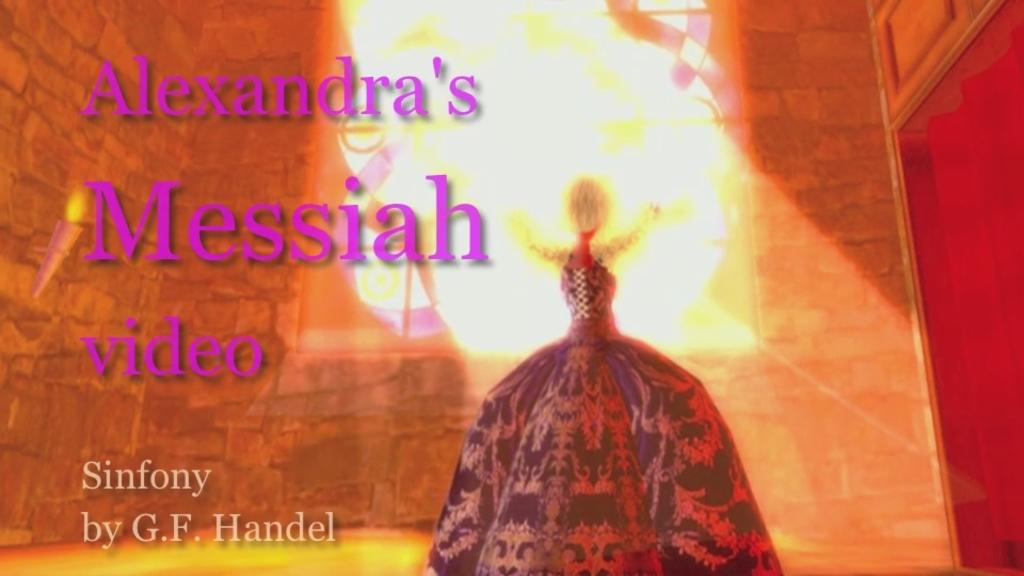<image>
Give a short and clear explanation of the subsequent image. The video being advertised is by G.F. Handel. 